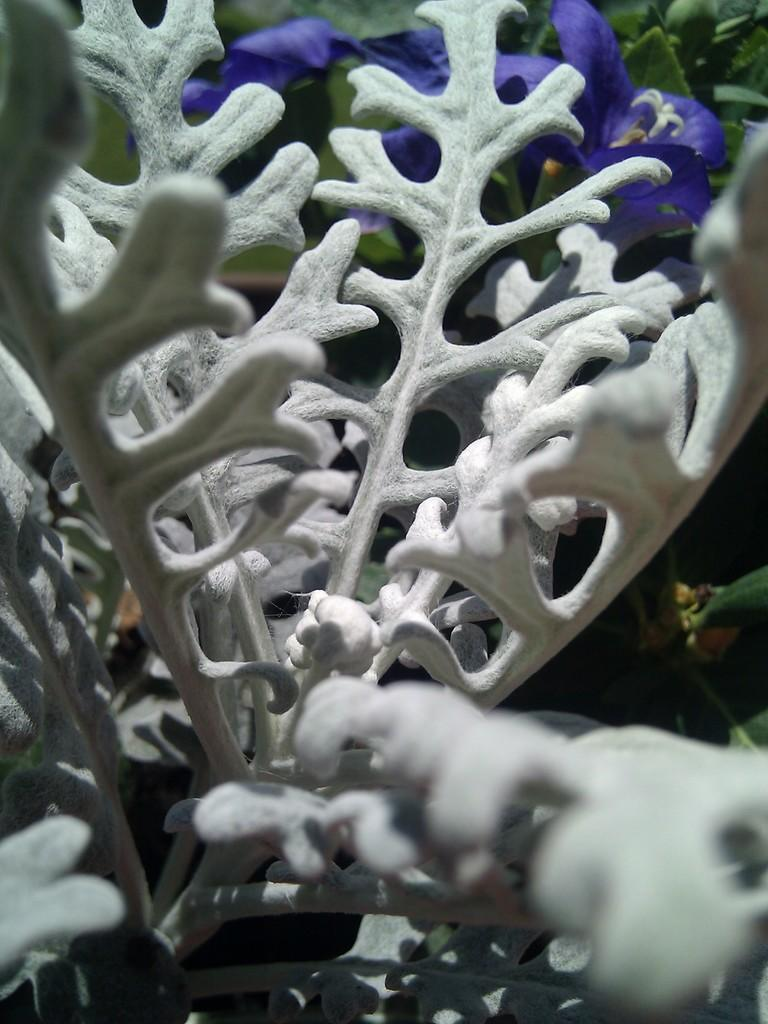What type of flora can be seen in the front of the image? There are flowers in the front of the image. What color are the flowers in the front? The flowers in the front are white in color. What can be seen in the background of the image? There are flowers and plants in the background of the image. How does the person in the image shake hands with the vest? There is no person or vest present in the image; it only features flowers and plants. 